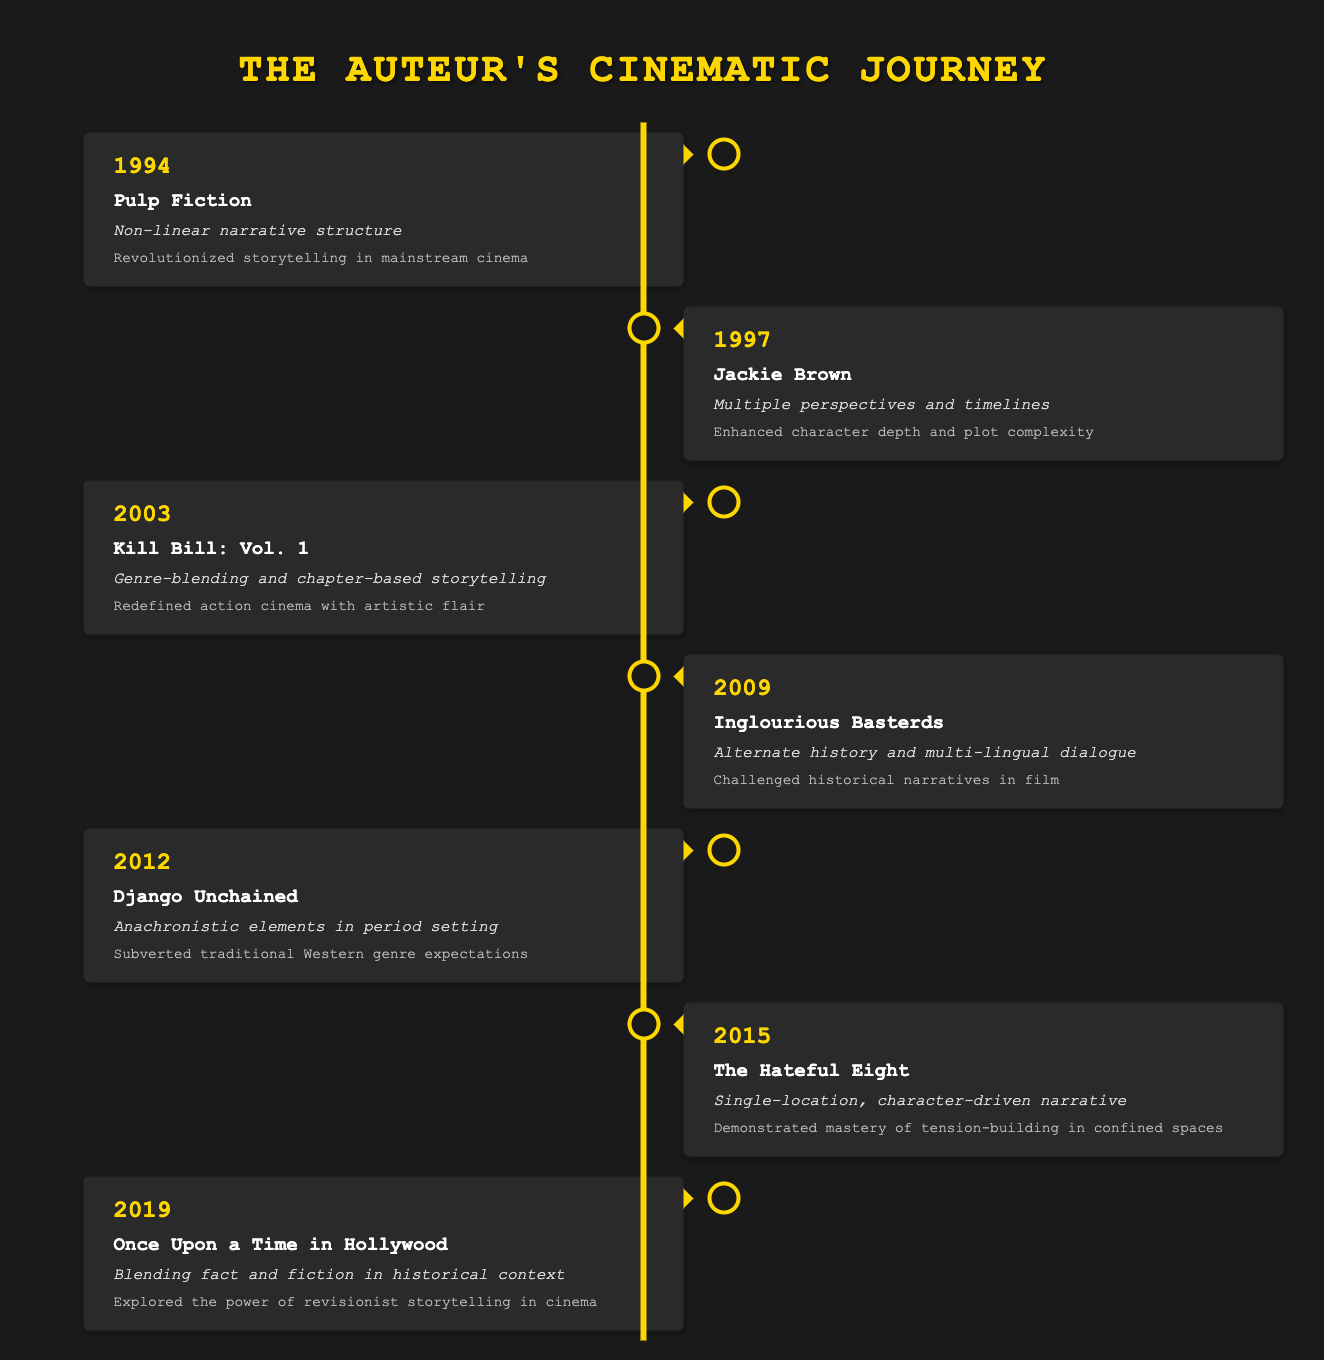What storytelling innovation was introduced in "Pulp Fiction"? The table indicates that "Pulp Fiction" introduced a non-linear narrative structure, which is specifically stated in the storytelling innovation column for the year 1994.
Answer: Non-linear narrative structure Which film project from 2009 features multi-lingual dialogue? According to the table, "Inglourious Basterds" is the film from 2009 that features multi-lingual dialogue as noted in the storytelling innovation section.
Answer: Inglourious Basterds How many projects utilized character-driven narratives up to 2015? In the timeline, "The Hateful Eight" (2015) is identified as a character-driven narrative. This was the only project from the years listed, so the count is one.
Answer: 1 Did "Django Unchained" subvert traditional Western genre expectations? The table confirms that the storytelling innovation in "Django Unchained" included anachronistic elements in a period setting, which implies a subversion of traditional Western genre expectations. Therefore, the answer is yes.
Answer: Yes Which storytelling innovation had the greatest impact on historical narratives? By examining the impacts listed, "Inglourious Basterds" (2009) is noted for challenging historical narratives, making it the project with the most significant impact in this area based on the table.
Answer: Alternate history and multi-lingual dialogue What is the average year of release for the films listed? The years from the table are 1994, 1997, 2003, 2009, 2012, 2015, and 2019. Adding these gives a total of  1994 + 1997 + 2003 + 2009 + 2012 + 2015 + 2019 = 14049. There are 7 films, so the average year is 14049 / 7 = 2007. This results in an average release year of 2007.
Answer: 2007 In which year did "Kill Bill: Vol. 1" redefine action cinema? The table states that "Kill Bill: Vol. 1" was released in 2003 and is noted for redefining action cinema, found in both the year and project columns.
Answer: 2003 How many films were released between 2003 and 2012? The projects released in this timeframe according to the table are "Kill Bill: Vol. 1" (2003), "Django Unchained" (2012). Therefore, there are two films in total.
Answer: 2 